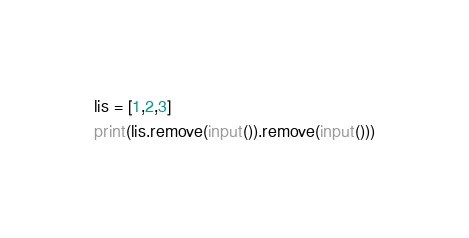<code> <loc_0><loc_0><loc_500><loc_500><_Python_>lis = [1,2,3]
print(lis.remove(input()).remove(input()))</code> 